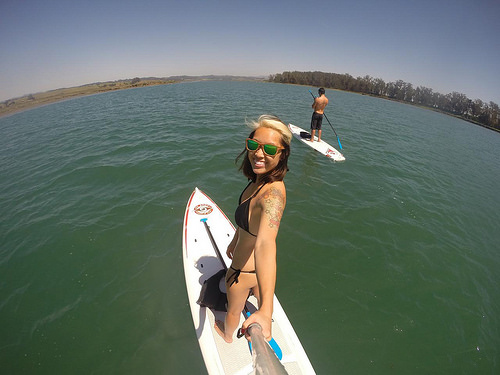<image>
Can you confirm if the water is on the boat? No. The water is not positioned on the boat. They may be near each other, but the water is not supported by or resting on top of the boat. Is there a women next to the sunglasses? No. The women is not positioned next to the sunglasses. They are located in different areas of the scene. 